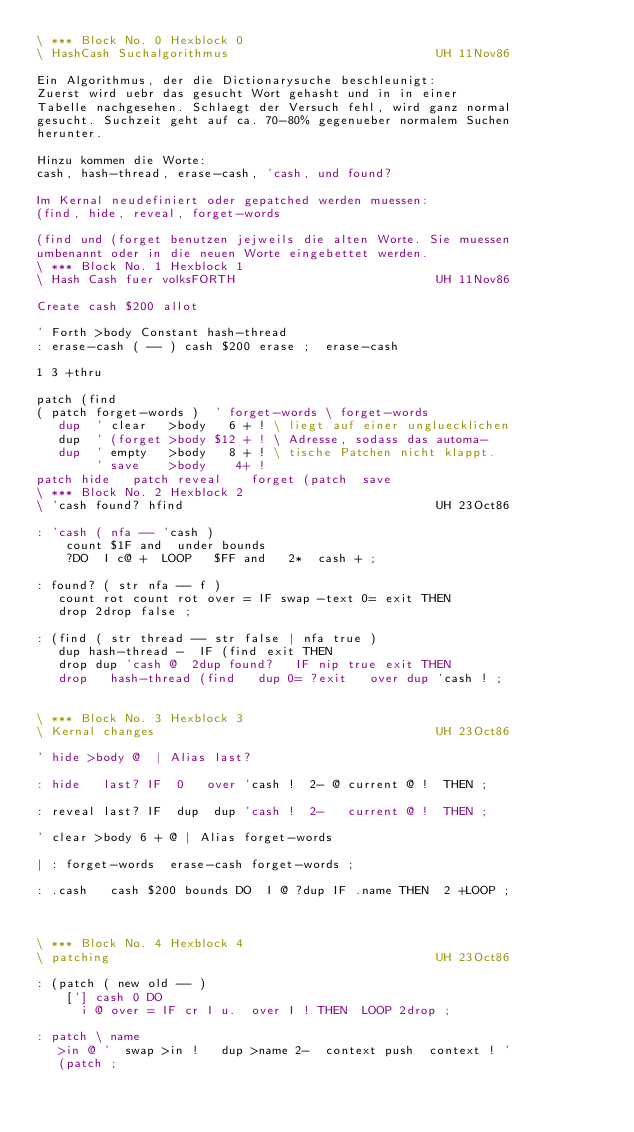<code> <loc_0><loc_0><loc_500><loc_500><_Forth_>\ *** Block No. 0 Hexblock 0 
\ HashCash Suchalgorithmus                            UH 11Nov86
                                                                
Ein Algorithmus, der die Dictionarysuche beschleunigt:          
Zuerst wird uebr das gesucht Wort gehasht und in in einer       
Tabelle nachgesehen. Schlaegt der Versuch fehl, wird ganz normal
gesucht. Suchzeit geht auf ca. 70-80% gegenueber normalem Suchen
herunter.                                                       
                                                                
Hinzu kommen die Worte:                                         
cash, hash-thread, erase-cash, 'cash, und found?                
                                                                
Im Kernal neudefiniert oder gepatched werden muessen:           
(find, hide, reveal, forget-words                               
                                                                
(find und (forget benutzen jejweils die alten Worte. Sie muessen
umbenannt oder in die neuen Worte eingebettet werden.           
\ *** Block No. 1 Hexblock 1 
\ Hash Cash fuer volksFORTH                           UH 11Nov86
                                                                
Create cash $200 allot                                          
                                                                
' Forth >body Constant hash-thread                              
: erase-cash ( -- ) cash $200 erase ;  erase-cash               
                                                                
1 3 +thru                                                       
                                                                
patch (find                                                     
( patch forget-words )  ' forget-words \ forget-words           
   dup  ' clear   >body   6 + ! \ liegt auf einer ungluecklichen
   dup  ' (forget >body $12 + ! \ Adresse, sodass das automa-   
   dup  ' empty   >body   8 + ! \ tische Patchen nicht klappt.  
        ' save    >body    4+ !                                 
patch hide   patch reveal    forget (patch  save                
\ *** Block No. 2 Hexblock 2 
\ 'cash found? hfind                                  UH 23Oct86
                                                                
: 'cash ( nfa -- 'cash )                                        
    count $1F and  under bounds                                 
    ?DO  I c@ +  LOOP   $FF and   2*  cash + ;                  
                                                                
: found? ( str nfa -- f )                                       
   count rot count rot over = IF swap -text 0= exit THEN        
   drop 2drop false ;                                           
                                                                
: (find ( str thread -- str false | nfa true )                  
   dup hash-thread -  IF (find exit THEN                        
   drop dup 'cash @  2dup found?   IF nip true exit THEN        
   drop   hash-thread (find   dup 0= ?exit   over dup 'cash ! ; 
                                                                
                                                                
\ *** Block No. 3 Hexblock 3 
\ Kernal changes                                      UH 23Oct86
                                                                
' hide >body @  | Alias last?                                   
                                                                
: hide   last? IF  0   over 'cash !  2- @ current @ !  THEN ;   
                                                                
: reveal last? IF  dup  dup 'cash !  2-   current @ !  THEN ;   
                                                                
' clear >body 6 + @ | Alias forget-words                        
                                                                
| : forget-words  erase-cash forget-words ;                     
                                                                
: .cash   cash $200 bounds DO  I @ ?dup IF .name THEN  2 +LOOP ;
                                                                
                                                                
                                                                
\ *** Block No. 4 Hexblock 4 
\ patching                                            UH 23Oct86
                                                                
: (patch ( new old -- )                                         
    ['] cash 0 DO                                               
      i @ over = IF cr I u.  over I ! THEN  LOOP 2drop ;        
                                                                
: patch \ name                                                  
   >in @ '  swap >in !   dup >name 2-  context push  context ! '
   (patch ;                                                     
                                                                
                                                                
                                                                
                                                                
                                                                
                                                                
                                                                
</code> 